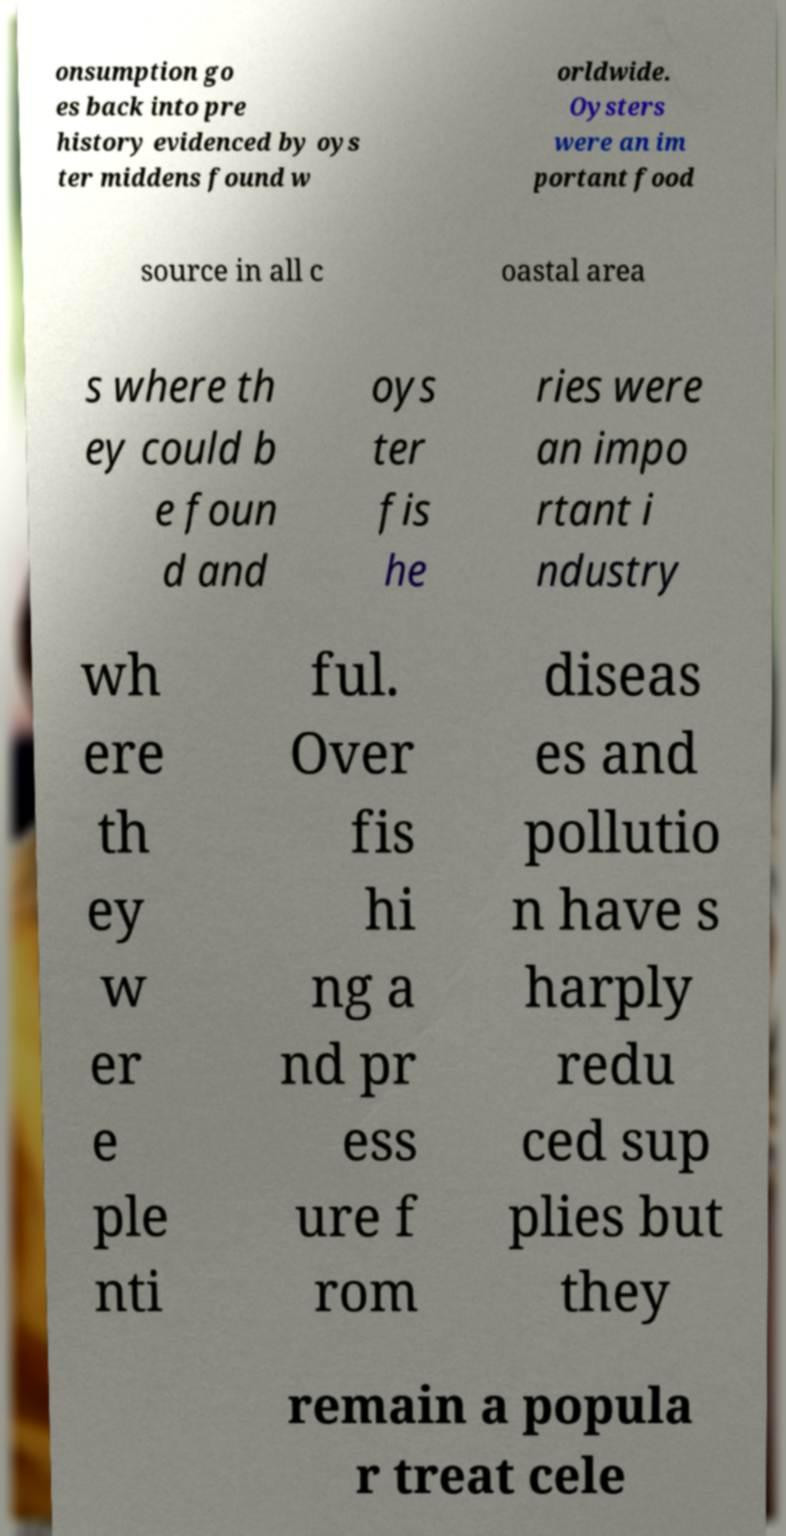I need the written content from this picture converted into text. Can you do that? onsumption go es back into pre history evidenced by oys ter middens found w orldwide. Oysters were an im portant food source in all c oastal area s where th ey could b e foun d and oys ter fis he ries were an impo rtant i ndustry wh ere th ey w er e ple nti ful. Over fis hi ng a nd pr ess ure f rom diseas es and pollutio n have s harply redu ced sup plies but they remain a popula r treat cele 